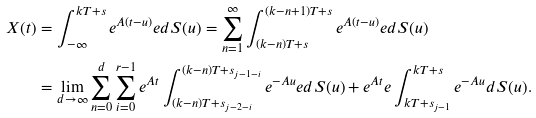<formula> <loc_0><loc_0><loc_500><loc_500>X ( t ) & = \int _ { - \infty } ^ { k T + s } e ^ { { A } ( t - u ) } { e } d S ( u ) = \sum _ { n = 1 } ^ { \infty } \int _ { ( k - n ) T + s } ^ { ( k - n + 1 ) T + s } e ^ { { A } ( t - u ) } { e } d S ( u ) \\ & = \lim _ { d \rightarrow \infty } \sum _ { n = 0 } ^ { d } \sum _ { i = 0 } ^ { r - 1 } e ^ { { A } t } \int _ { ( k - n ) T + s _ { j - 2 - i } } ^ { ( k - n ) T + s _ { j - 1 - i } } e ^ { - { A } u } { e } d S ( u ) + e ^ { { A } t } { e } \int _ { k T + s _ { j - 1 } } ^ { k T + s } e ^ { - { A } u } d S ( u ) .</formula> 